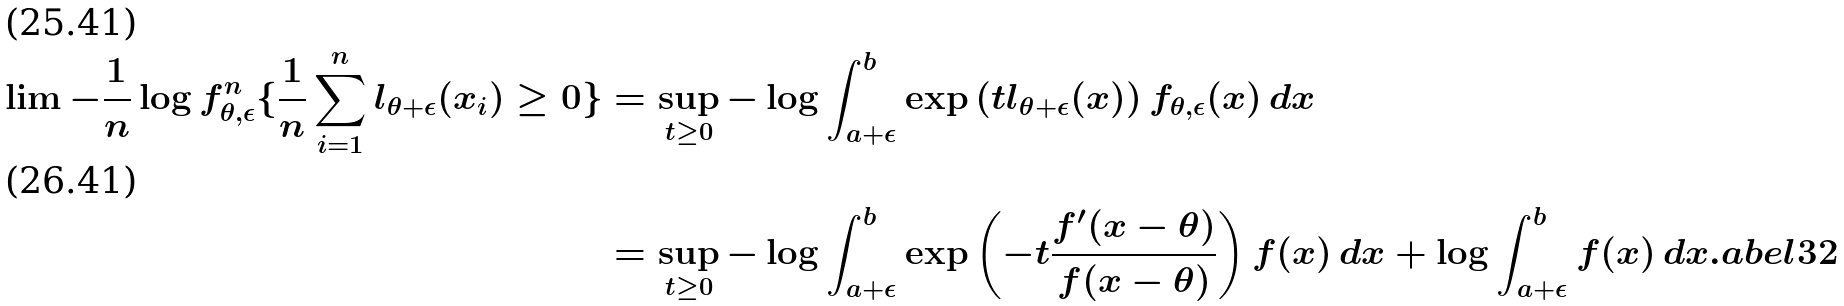Convert formula to latex. <formula><loc_0><loc_0><loc_500><loc_500>\lim - \frac { 1 } { n } \log f _ { \theta , \epsilon } ^ { n } \{ \frac { 1 } { n } \sum _ { i = 1 } ^ { n } l _ { \theta + \epsilon } ( x _ { i } ) \geq 0 \} & = \sup _ { t \geq 0 } - \log \int _ { a + \epsilon } ^ { b } \exp \left ( t l _ { \theta + \epsilon } ( x ) \right ) f _ { \theta , \epsilon } ( x ) \, d x \\ & = \sup _ { t \geq 0 } - \log \int _ { a + \epsilon } ^ { b } \exp \left ( - t \frac { f ^ { \prime } ( x - \theta ) } { f ( x - \theta ) } \right ) f ( x ) \, d x + \log \int _ { a + \epsilon } ^ { b } f ( x ) \, d x . \L a b e l { 3 2 }</formula> 